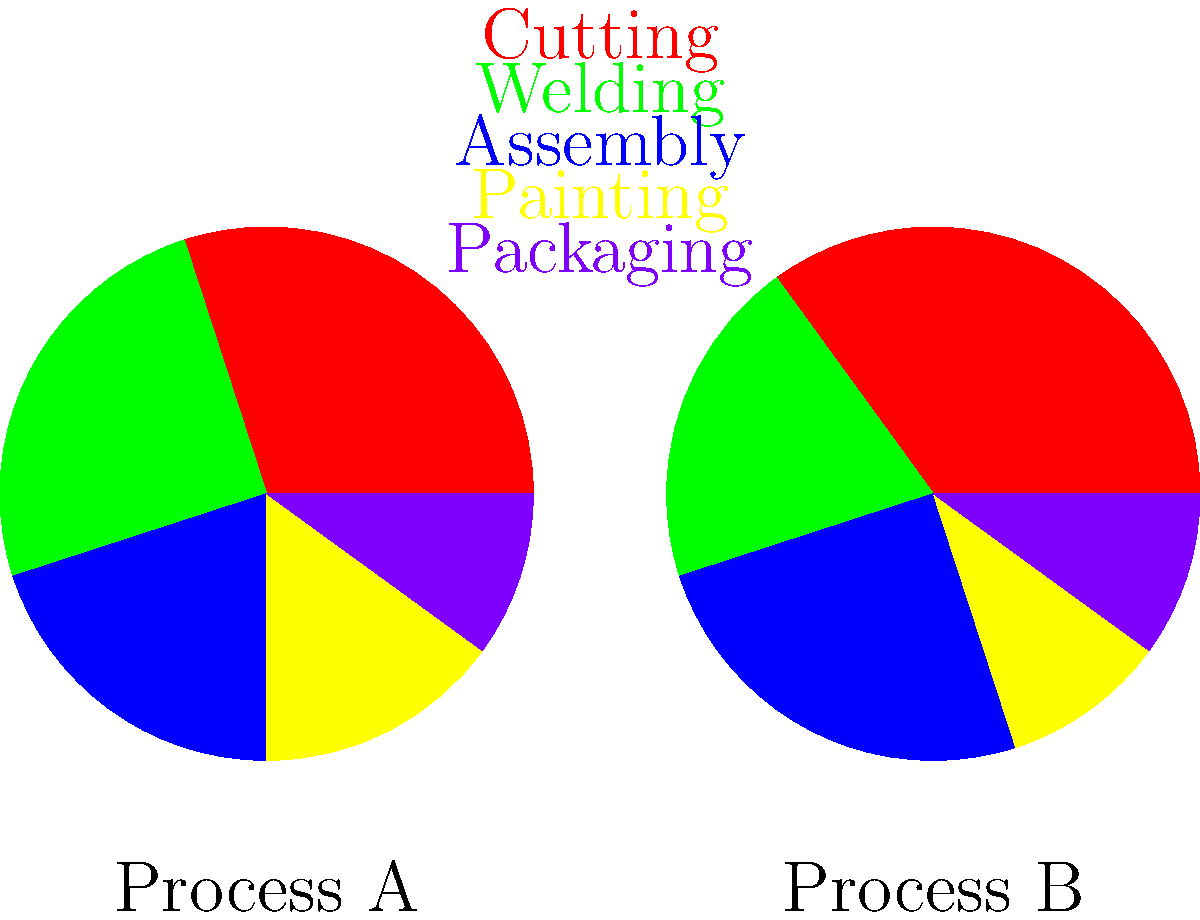As a manufacturing company utilizing algorithmic automation, you're analyzing energy consumption data of two competing production processes. The pie charts represent the energy distribution across different stages for Process A and Process B. Which process is more energy-efficient in the welding stage, and by what percentage difference? To solve this problem, we need to follow these steps:

1. Identify the welding stage (green sector) in both pie charts.

2. Calculate the percentage of energy consumed by welding in each process:
   Process A: 25% of total energy
   Process B: 20% of total energy

3. Calculate the difference in energy consumption for welding:
   $25\% - 20\% = 5\%$

4. To find the percentage difference, we use the formula:
   $\text{Percentage Difference} = \frac{\text{Difference}}{\text{Average}} \times 100\%$

   $\text{Average} = \frac{25\% + 20\%}{2} = 22.5\%$

   $\text{Percentage Difference} = \frac{5\%}{22.5\%} \times 100\% \approx 22.22\%$

5. Determine which process is more energy-efficient in welding:
   Process B consumes less energy (20%) compared to Process A (25%), so Process B is more energy-efficient.

Therefore, Process B is more energy-efficient in the welding stage, with a percentage difference of approximately 22.22%.
Answer: Process B, 22.22% 